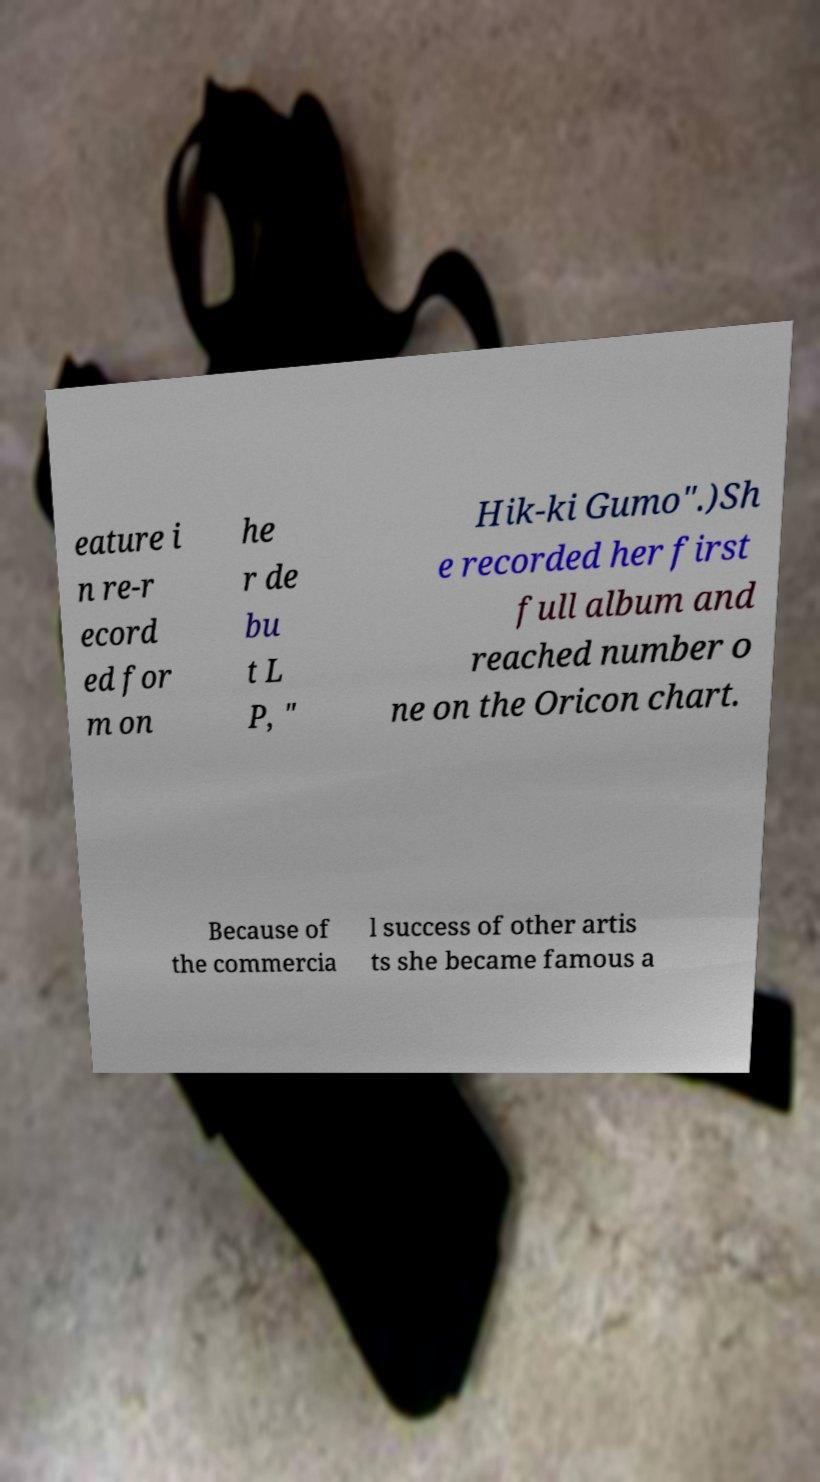Could you extract and type out the text from this image? eature i n re-r ecord ed for m on he r de bu t L P, " Hik-ki Gumo".)Sh e recorded her first full album and reached number o ne on the Oricon chart. Because of the commercia l success of other artis ts she became famous a 